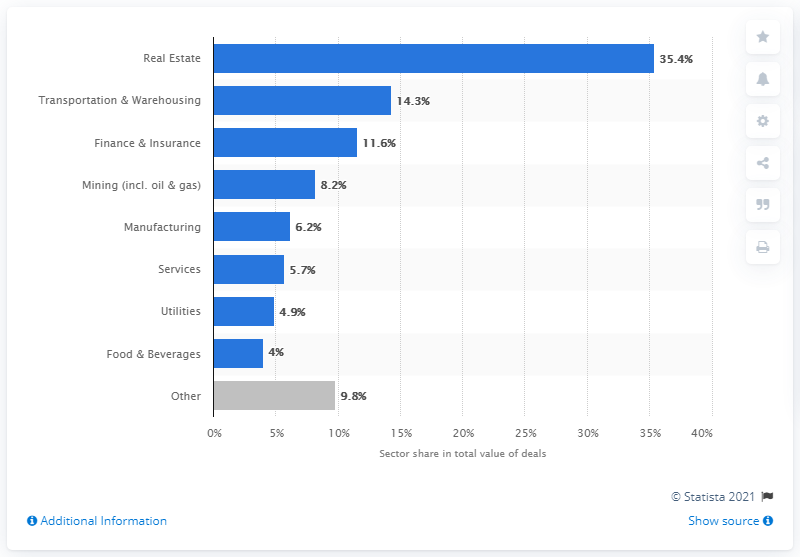Mention a couple of crucial points in this snapshot. According to the given percentage, transportation and warehousing accounted for approximately 14.3% of Poland's market share. In Poland's real estate industry, deals made up 35.4% of the total transactions worth. 